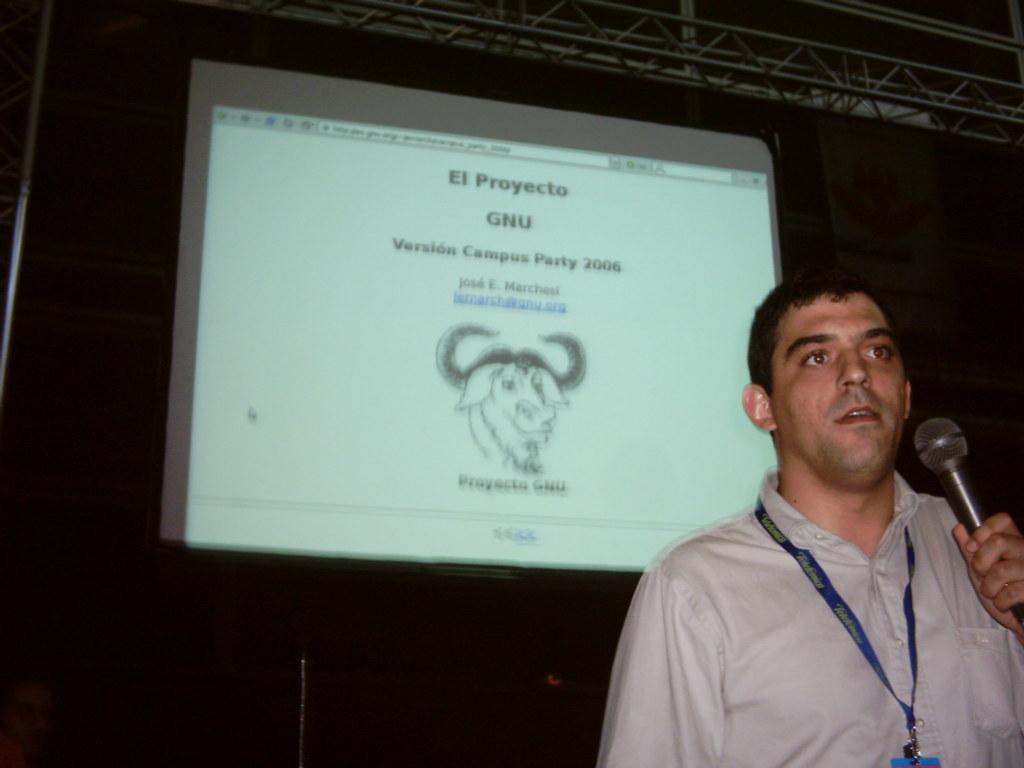Who is the main subject in the image? There is a person in the image. What is the person holding in his hand? The person is holding a microphone in his hand. What can be seen on the display in the image? The display shows "Campus Party 2006". What might be the purpose of the microphone in the image? The person holding the microphone might be giving a speech or presentation at the Campus Party event. What is the person's father doing in the image? There is no information about the person's father in the image, so we cannot answer this question. 